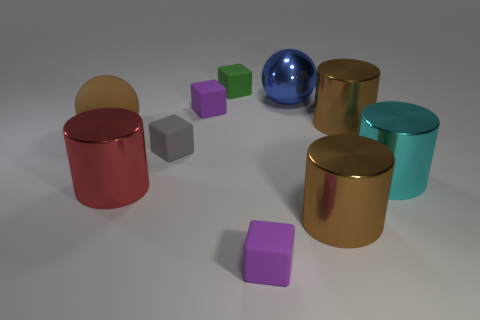Is there a big thing of the same color as the large matte sphere?
Give a very brief answer. Yes. What number of gray objects are either metallic objects or big metallic cylinders?
Your answer should be compact. 0. How many other things are the same size as the red shiny cylinder?
Your answer should be compact. 5. What number of large objects are green rubber cubes or brown objects?
Ensure brevity in your answer.  3. Is the size of the red cylinder the same as the purple rubber block behind the cyan shiny cylinder?
Make the answer very short. No. What number of other objects are there of the same shape as the large cyan thing?
Keep it short and to the point. 3. What is the shape of the small gray thing that is made of the same material as the small green cube?
Your response must be concise. Cube. Are any large cyan objects visible?
Keep it short and to the point. Yes. Is the number of metal things that are behind the red shiny cylinder less than the number of metallic balls in front of the large blue object?
Your answer should be compact. No. There is a tiny gray thing to the left of the shiny ball; what is its shape?
Your answer should be very brief. Cube. 